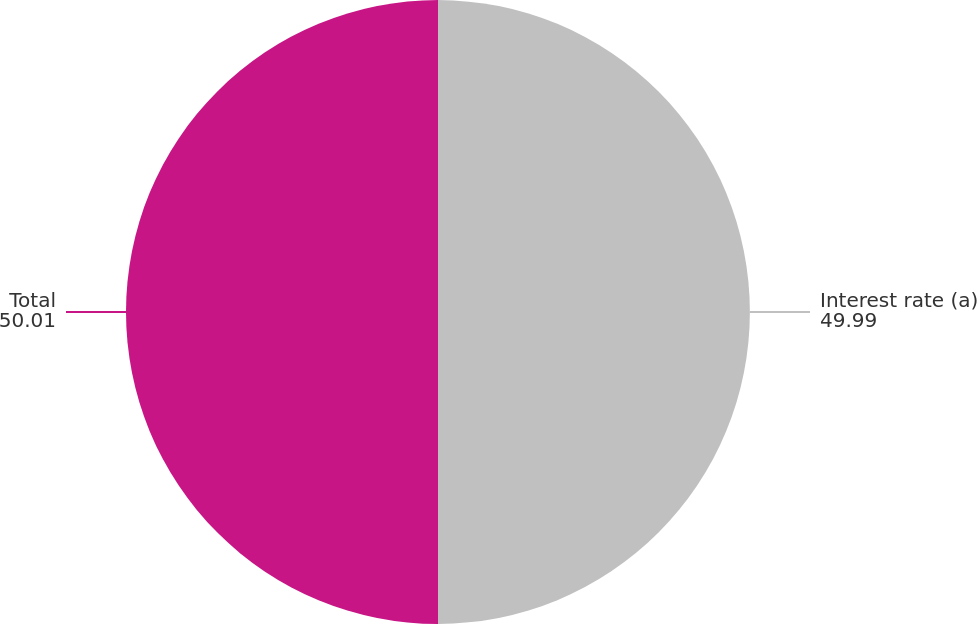Convert chart. <chart><loc_0><loc_0><loc_500><loc_500><pie_chart><fcel>Interest rate (a)<fcel>Total<nl><fcel>49.99%<fcel>50.01%<nl></chart> 